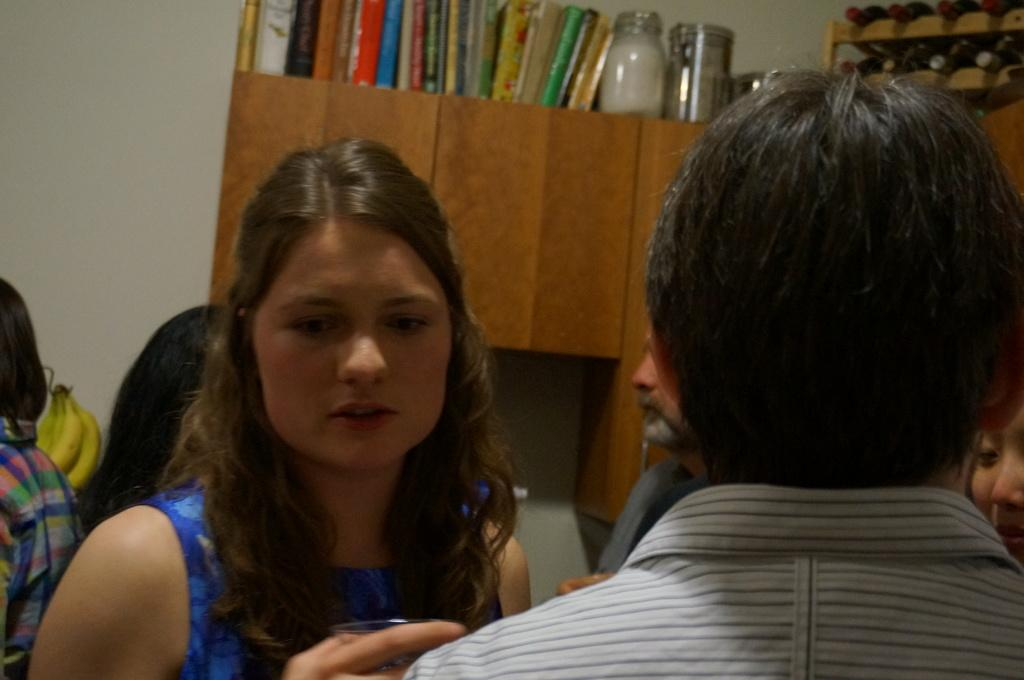Provide a one-sentence caption for the provided image. Several people stand below a cabinet with books on top of it, one being "The Joy of Cooking.". 